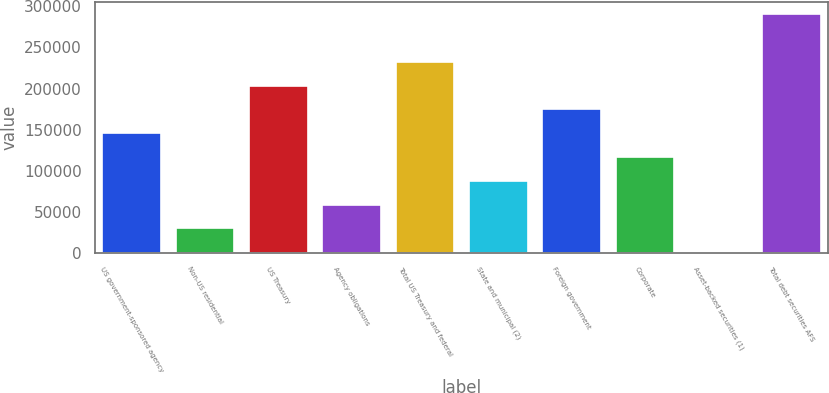Convert chart. <chart><loc_0><loc_0><loc_500><loc_500><bar_chart><fcel>US government-sponsored agency<fcel>Non-US residential<fcel>US Treasury<fcel>Agency obligations<fcel>Total US Treasury and federal<fcel>State and municipal (2)<fcel>Foreign government<fcel>Corporate<fcel>Asset-backed securities (1)<fcel>Total debt securities AFS<nl><fcel>145634<fcel>29802.8<fcel>203550<fcel>58760.6<fcel>232507<fcel>87718.4<fcel>174592<fcel>116676<fcel>845<fcel>290423<nl></chart> 